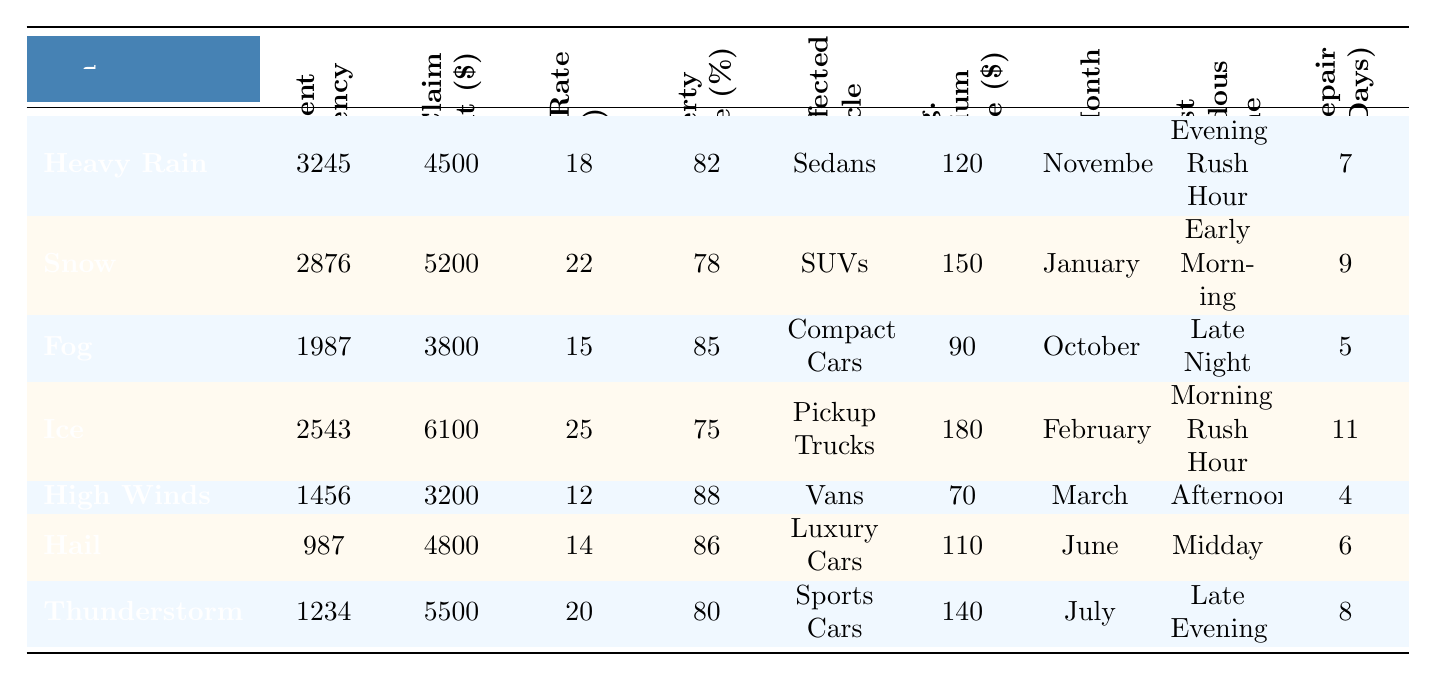What is the accident frequency for Heavy Rain? The accident frequency for Heavy Rain is listed directly in the table under the "Accident Frequency" column. It shows 3245 for Heavy Rain.
Answer: 3245 What is the average claim amount associated with Snow-related accidents? To find the average claim amount for Snow, we look under the "Avg. Claim Amount" column for Snow, which displays 5200.
Answer: 5200 Which weather condition has the highest injury rate percentage? By comparing the values in the "Injury Rate (%)" column, we see that Ice has the highest rate at 25%.
Answer: Ice What is the average premium increase for accidents caused by Hail? The average premium increase for Hail can be found in the "Avg. Premium Increase ($)" column, showing a value of 110.
Answer: 110 How does the Injury Rate Percentage for Heavy Rain compare to that of High Winds? The injury rate percentage for Heavy Rain is 18%, while for High Winds it's 12%. The difference is 6%.
Answer: 6% What is the total number of accidents across all weather conditions listed in the table? To find the total, we sum the accident frequencies: 3245 + 2876 + 1987 + 2543 + 1456 + 987 + 1234 = 14528.
Answer: 14528 Is the average claim amount for accidents during a Thunderstorm higher than that during a Fog-related accident? The average claim for Thunderstorm is 5500 and for Fog is 3800. Since 5500 > 3800, the statement is true.
Answer: Yes Which month has the highest average premium increase based on the table? Checking the "Avg. Premium Increase ($)" column, Ice has the highest with 180, which corresponds to February.
Answer: February If a vehicle affected by Snow has an accident, what is the likelihood of injury based on the injury rate percentage? The injury rate percentage for Snow is 22%, meaning there is a 22% chance of injury during a Snow-related accident.
Answer: 22% What is the average repair time for accidents caused by Ice? By looking at the "Avg. Repair Time (Days)" column for Ice, we can see the average repair time is 11 days.
Answer: 11 days What is the relationship between accident frequency and average claim amount for Hail-related incidents? The accident frequency for Hail is 987, and the average claim amount is 4800. There’s no direct mathematical relationship without further calculation, but it shows lower accident frequency with moderate claim amounts.
Answer: Moderate claim amounts Which type of vehicle is most affected by Snow-related accidents? Referring to the "Most Affected Vehicle" column for Snow, the most affected vehicle type is SUVs.
Answer: SUVs What month sees the peak accidents due to Heavy Rain? The "Peak Month" column indicates November for Heavy Rain accidents.
Answer: November On average, how many days does it take to repair vehicles involved in accidents during High Winds? In the "Avg. Repair Time (Days)" column, High Winds shows an average of 4 days for repairs.
Answer: 4 days Which weather event has the highest percentage of property damage based on the data? The "Property Damage (%)" column shows High Winds has the highest percentage at 88%.
Answer: High Winds 